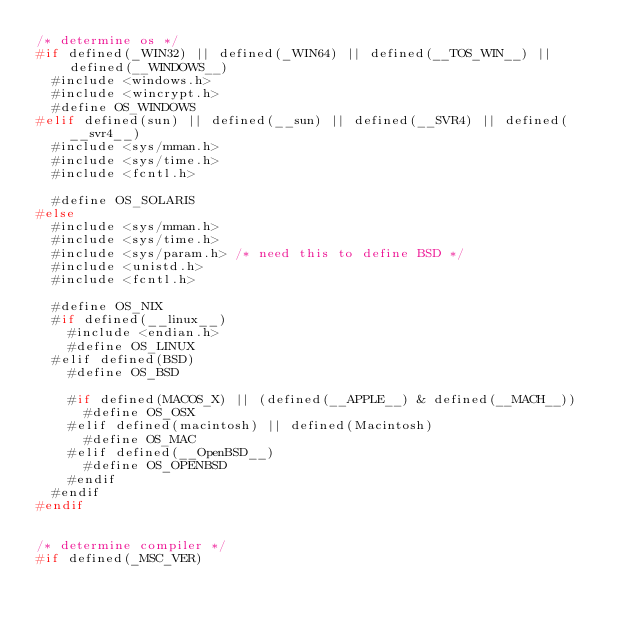<code> <loc_0><loc_0><loc_500><loc_500><_C_>/* determine os */
#if defined(_WIN32)	|| defined(_WIN64) || defined(__TOS_WIN__) || defined(__WINDOWS__)
	#include <windows.h>
	#include <wincrypt.h>
	#define OS_WINDOWS
#elif defined(sun) || defined(__sun) || defined(__SVR4) || defined(__svr4__)
	#include <sys/mman.h>
	#include <sys/time.h>
	#include <fcntl.h>

	#define OS_SOLARIS
#else
	#include <sys/mman.h>
	#include <sys/time.h>
	#include <sys/param.h> /* need this to define BSD */
	#include <unistd.h>
	#include <fcntl.h>

	#define OS_NIX
	#if defined(__linux__)
		#include <endian.h>
		#define OS_LINUX
	#elif defined(BSD)
		#define OS_BSD

		#if defined(MACOS_X) || (defined(__APPLE__) & defined(__MACH__))
			#define OS_OSX
		#elif defined(macintosh) || defined(Macintosh)
			#define OS_MAC
		#elif defined(__OpenBSD__)
			#define OS_OPENBSD
		#endif
	#endif
#endif


/* determine compiler */
#if defined(_MSC_VER)</code> 